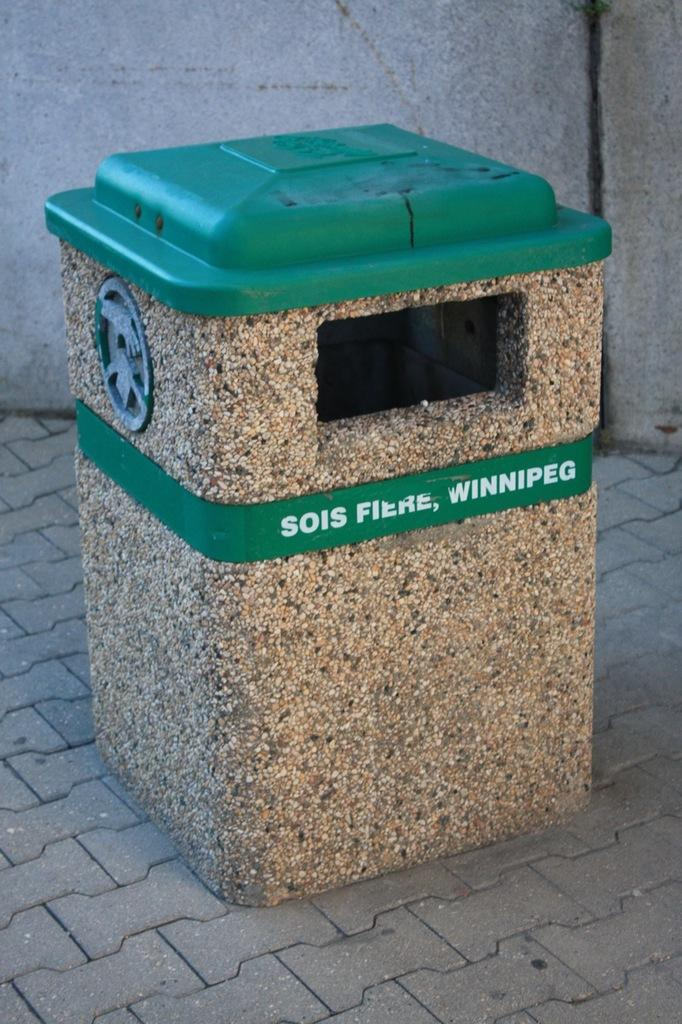<image>
Summarize the visual content of the image. A public trash can with Sois Fiere, Winnipeg on the side of it. 